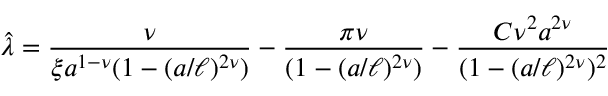<formula> <loc_0><loc_0><loc_500><loc_500>{ \hat { \lambda } } = { \frac { \nu } { \xi a ^ { 1 - \nu } ( 1 - ( a / \ell ) ^ { 2 \nu } ) } } - { \frac { \pi \nu } { ( 1 - ( a / \ell ) ^ { 2 \nu } ) } } - { \frac { C \nu ^ { 2 } a ^ { 2 \nu } } { ( 1 - ( a / \ell ) ^ { 2 \nu } ) ^ { 2 } } }</formula> 